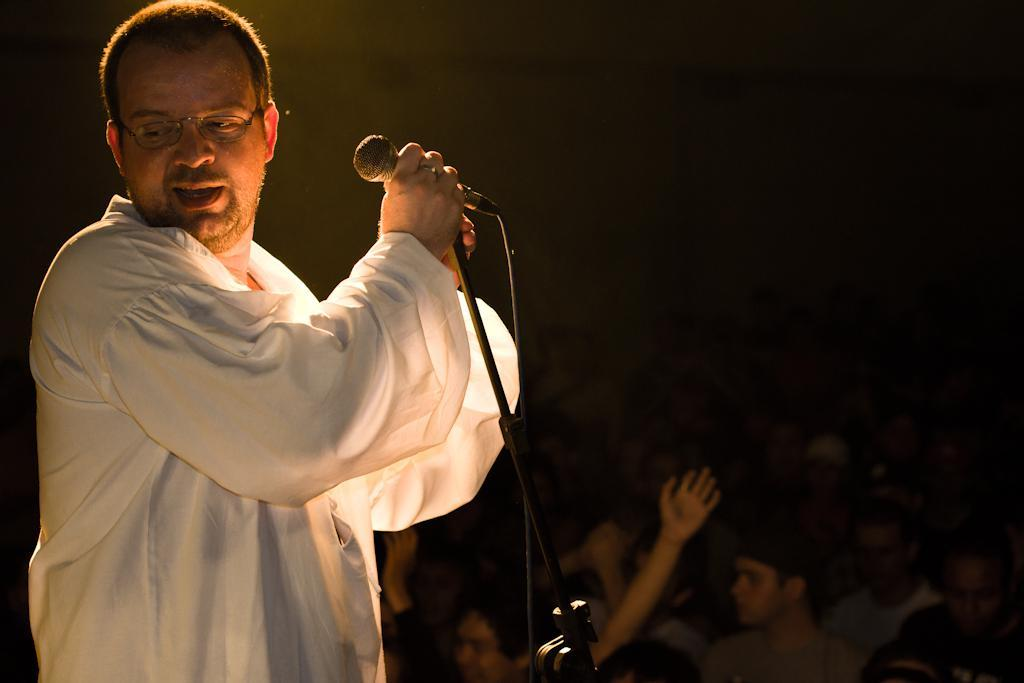What is the person in the image wearing? There is a person wearing a white dress in the image. What is the person with the white dress doing in the image? The person is standing in front of a mic. Can you describe the people around the person with the white dress? There are other people visible in the image. What color is the background of the image? The background of the image is black. How does the person in the white dress react to the sneeze of the person next to them in the image? There is no sneeze or reaction to a sneeze visible in the image. 